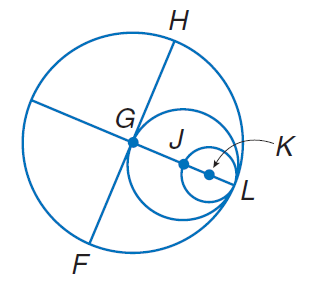Question: Circles G, J, and K all intersect at L. If G H = 10, find J K.
Choices:
A. 2.5
B. 5
C. 10
D. 15
Answer with the letter. Answer: A Question: Circles G, J, and K all intersect at L. If G H = 10. Find G J.
Choices:
A. 5
B. 10
C. 20
D. 25
Answer with the letter. Answer: A Question: Circles G, J, and K all intersect at L. If G H = 10, find G L.
Choices:
A. 10
B. 20
C. 25
D. 35
Answer with the letter. Answer: A 